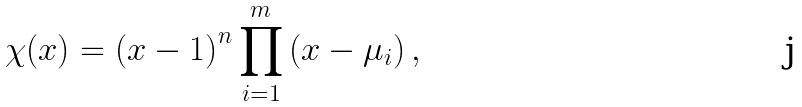Convert formula to latex. <formula><loc_0><loc_0><loc_500><loc_500>\chi ( x ) = \left ( x - 1 \right ) ^ { n } \prod _ { i = 1 } ^ { m } \left ( x - \mu _ { i } \right ) ,</formula> 